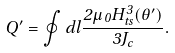Convert formula to latex. <formula><loc_0><loc_0><loc_500><loc_500>Q ^ { \prime } = \oint d l \frac { 2 \mu _ { 0 } H ^ { 3 } _ { t s } ( \theta ^ { \prime } ) } { 3 J _ { c } } .</formula> 